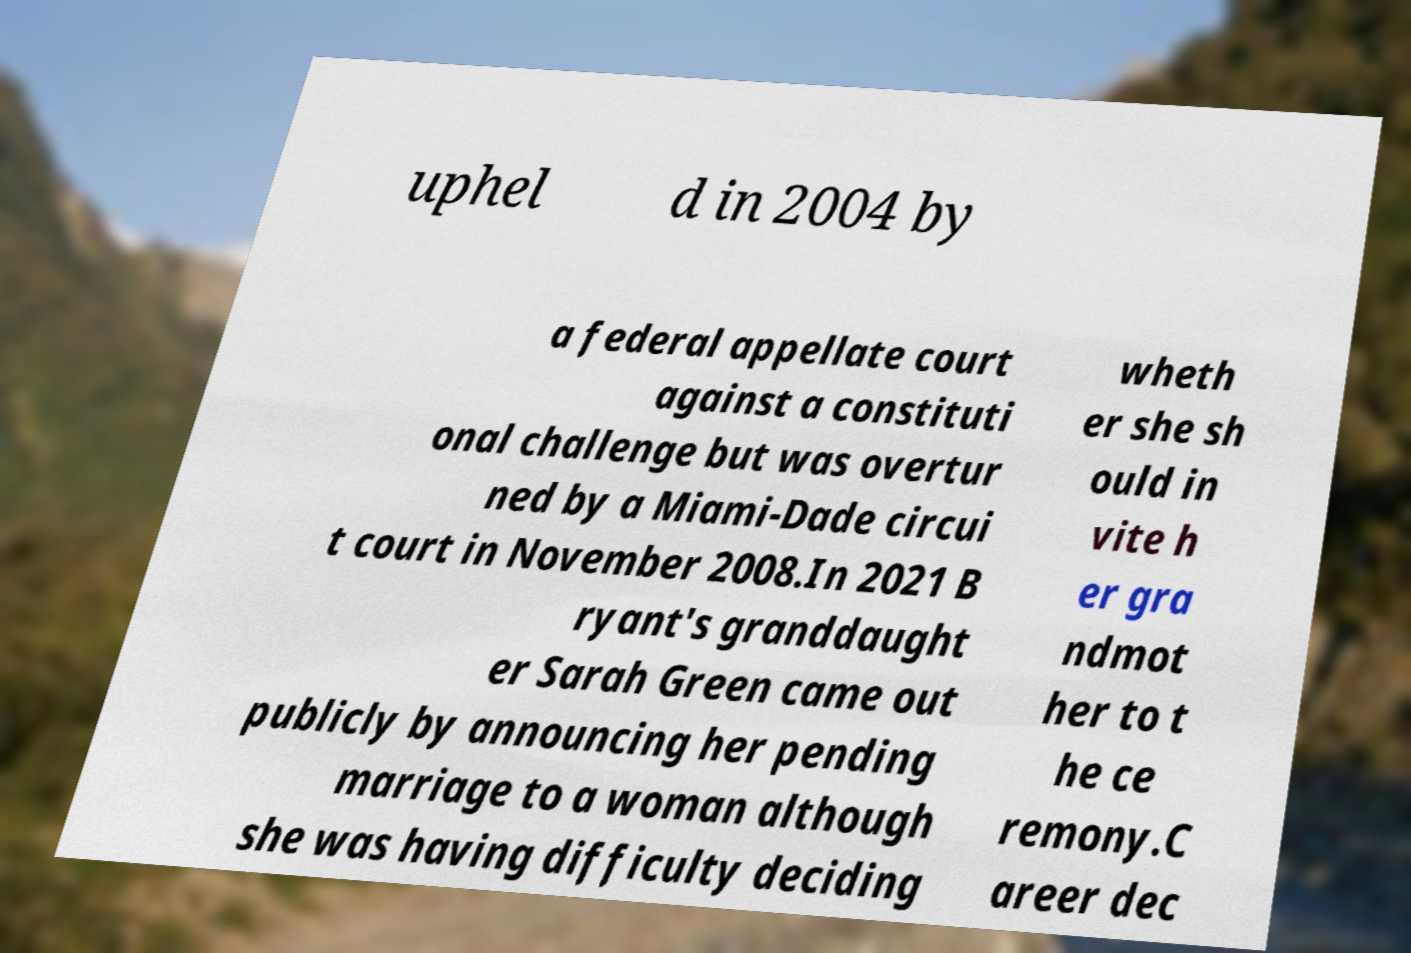There's text embedded in this image that I need extracted. Can you transcribe it verbatim? uphel d in 2004 by a federal appellate court against a constituti onal challenge but was overtur ned by a Miami-Dade circui t court in November 2008.In 2021 B ryant's granddaught er Sarah Green came out publicly by announcing her pending marriage to a woman although she was having difficulty deciding wheth er she sh ould in vite h er gra ndmot her to t he ce remony.C areer dec 